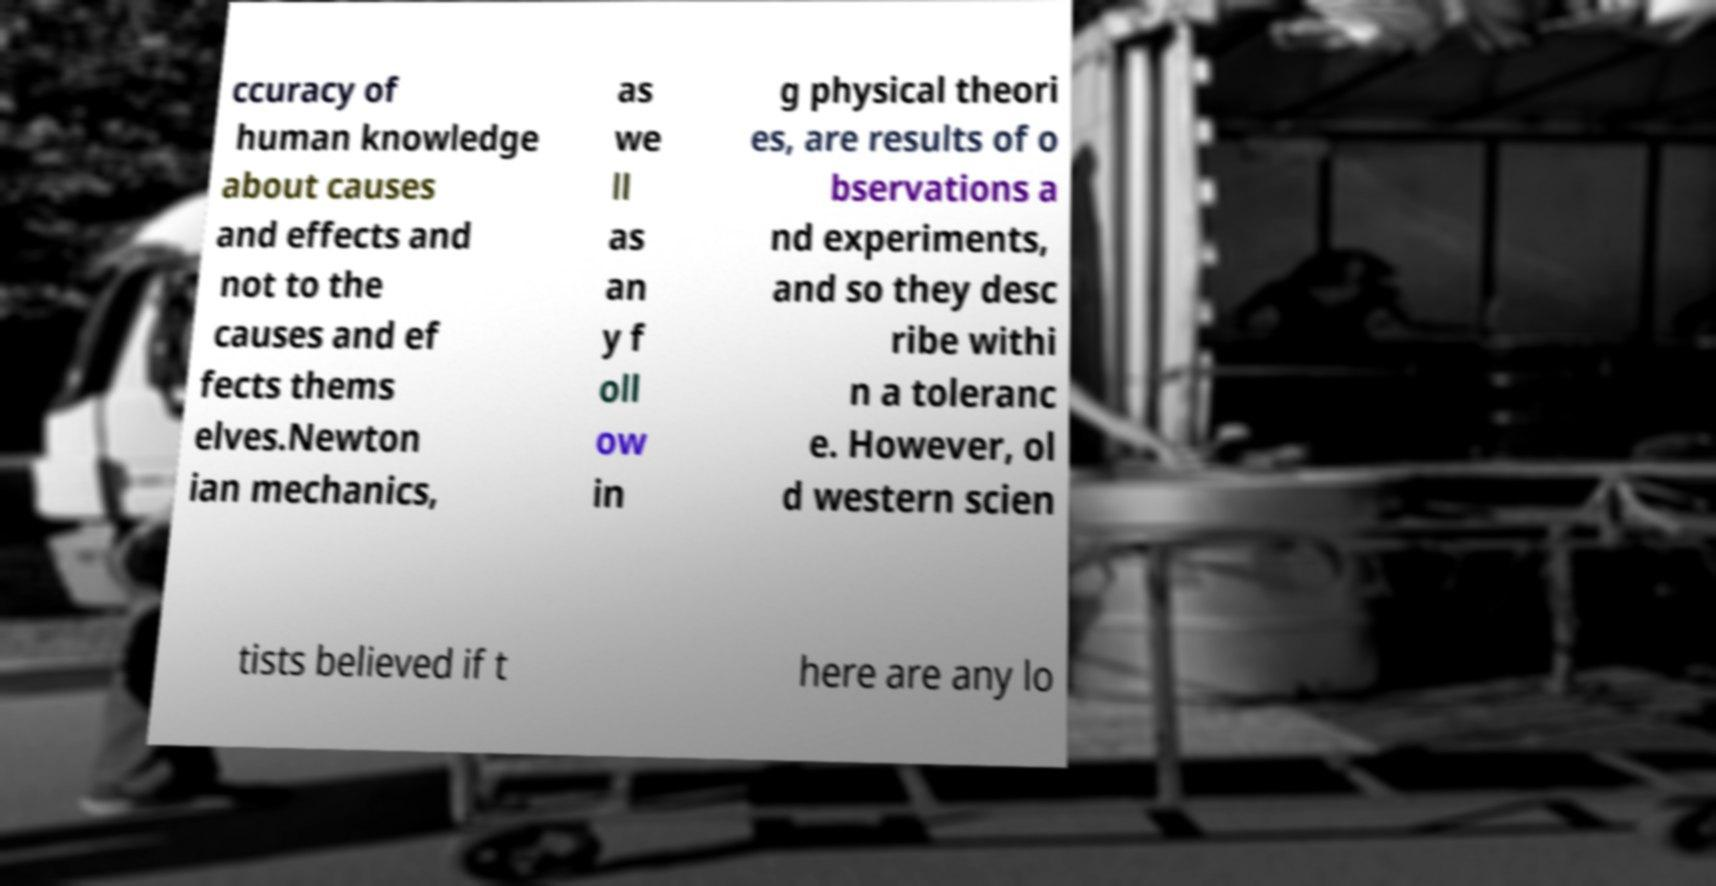Please identify and transcribe the text found in this image. ccuracy of human knowledge about causes and effects and not to the causes and ef fects thems elves.Newton ian mechanics, as we ll as an y f oll ow in g physical theori es, are results of o bservations a nd experiments, and so they desc ribe withi n a toleranc e. However, ol d western scien tists believed if t here are any lo 